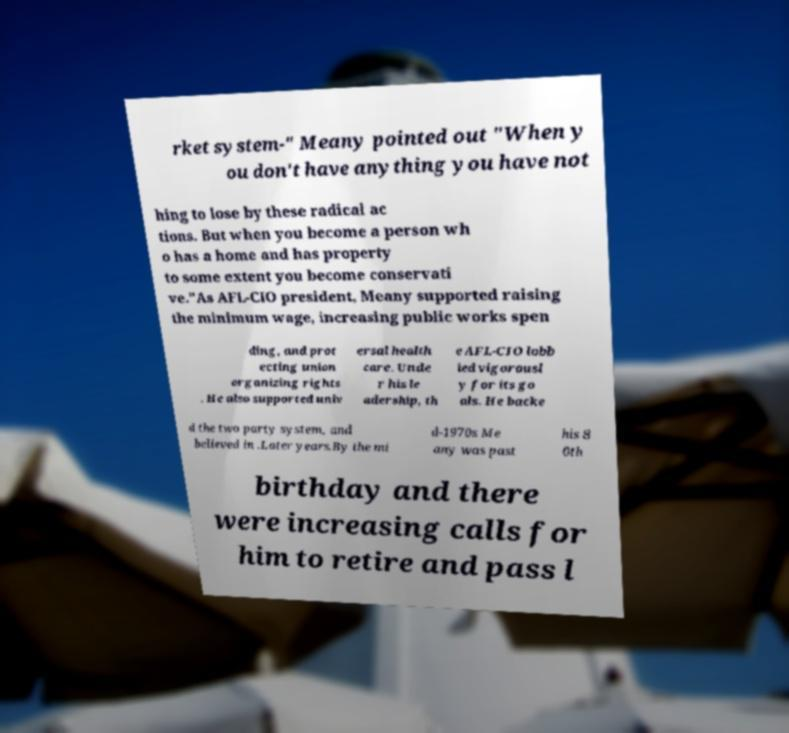Could you assist in decoding the text presented in this image and type it out clearly? rket system-" Meany pointed out "When y ou don't have anything you have not hing to lose by these radical ac tions. But when you become a person wh o has a home and has property to some extent you become conservati ve."As AFL-CIO president, Meany supported raising the minimum wage, increasing public works spen ding, and prot ecting union organizing rights . He also supported univ ersal health care. Unde r his le adership, th e AFL-CIO lobb ied vigorousl y for its go als. He backe d the two party system, and believed in .Later years.By the mi d-1970s Me any was past his 8 0th birthday and there were increasing calls for him to retire and pass l 